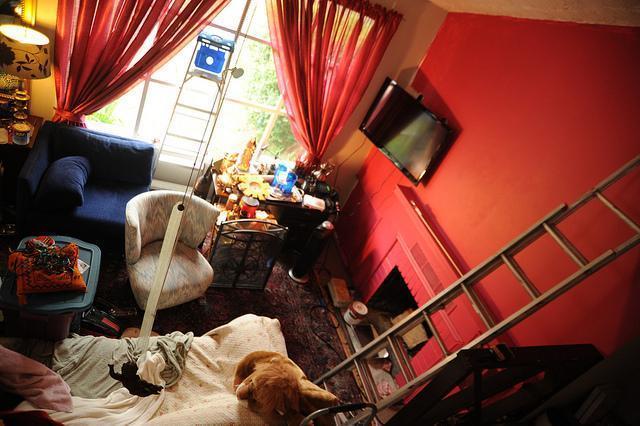How many ladders are there?
Give a very brief answer. 2. How many chairs are there?
Give a very brief answer. 3. How many giraffes are in the picture?
Give a very brief answer. 0. 